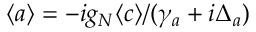Convert formula to latex. <formula><loc_0><loc_0><loc_500><loc_500>\langle a \rangle = - i g _ { N } \langle c \rangle / ( \gamma _ { a } + i \Delta _ { a } )</formula> 